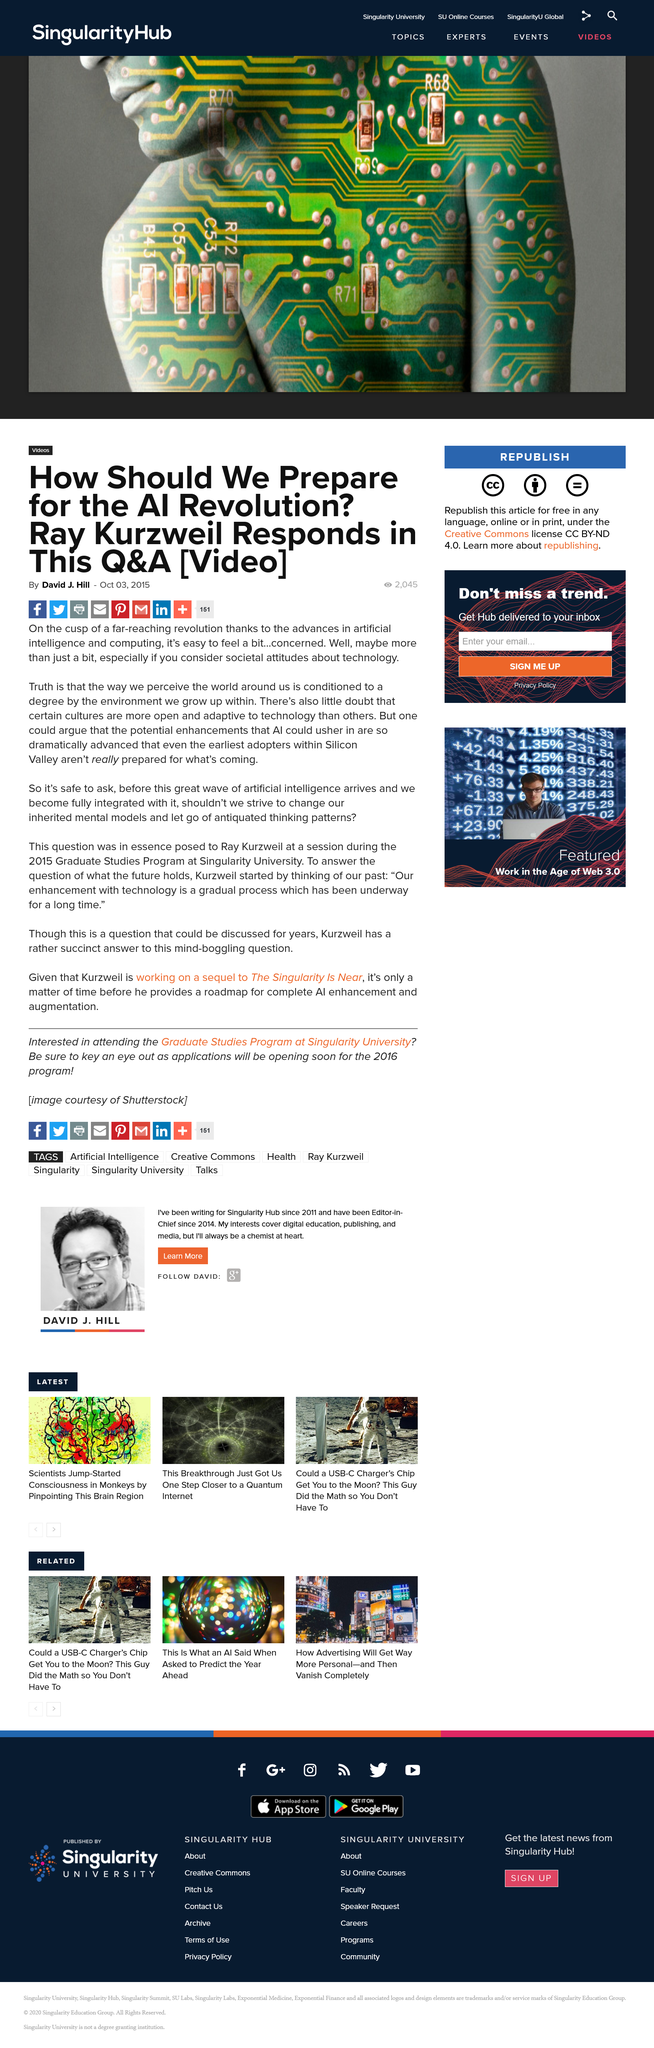List a handful of essential elements in this visual. The advancements in artificial intelligence and computing have made it easy for individuals to feel concerned about the potential for a far-reaching revolution. The gradual process of our enhancement with technology has been ongoing for an extended period of time. On April 12, 2015, the question regarding the relationship between human and non-human intelligence was posed to Ray Kurzweil during a session of the Graduate Studies Program at Singularity University. 